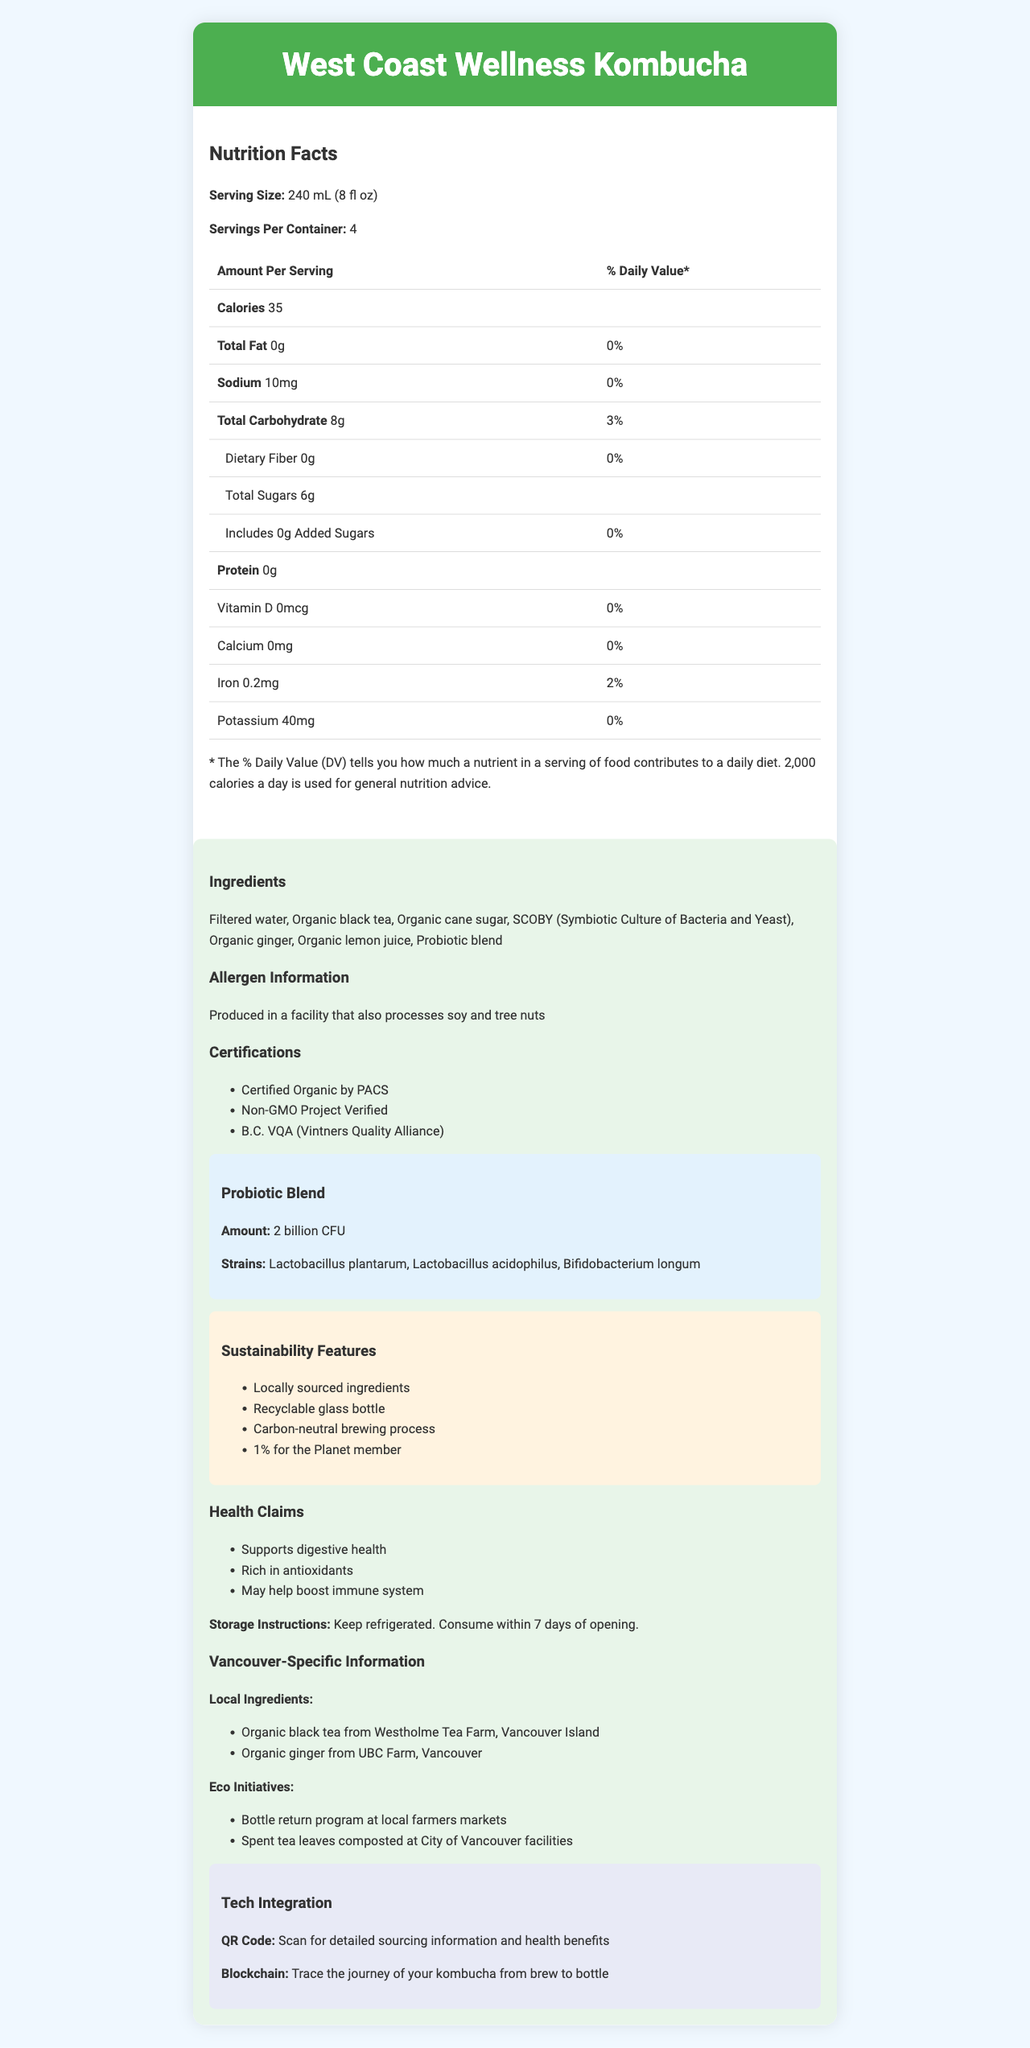how many servings are in a container? The document states that there are 4 servings per container.
Answer: 4 what is the serving size of the kombucha? The document lists the serving size as 240 mL (8 fl oz).
Answer: 240 mL (8 fl oz) how many calories are in one serving? The document indicates that each serving contains 35 calories.
Answer: 35 is there any fat in the West Coast Wellness Kombucha? The total fat amount is listed as 0g, which means there is no fat in the kombucha.
Answer: No what type of probiotics are included? The probiotics strains listed in the probiotic blend section are Lactobacillus plantarum, Lactobacillus acidophilus, and Bifidobacterium longum.
Answer: Lactobacillus plantarum, Lactobacillus acidophilus, Bifidobacterium longum which certification does the kombucha NOT have? A. Certified Organic by PACS B. Non-GMO Project Verified C. USDA Organic The document states that the kombucha is Certified Organic by PACS and Non-GMO Project Verified but does not mention USDA Organic.
Answer: C what is the amount of iron per serving? A. 0.1mg B. 0.2mg C. 0.3mg D. 0.4mg The document lists the iron content as 0.2mg per serving.
Answer: B should the kombucha be kept refrigerated after opening? The storage instructions mention that the kombucha should be refrigerated and consumed within 7 days of opening.
Answer: Yes does the product contain added sugars? The document states that the kombucha contains 0g of added sugars.
Answer: No is the kombucha bottle recyclable? The sustainability features list "Recyclable glass bottle" as one of its attributes.
Answer: Yes summarize the main idea of the document. The document outlines the kombucha's nutritional information and additional beneficial attributes like probiotics, uses of local and sustainable ingredients, technological integrations for traceability, and eco-friendly initiatives, making it appealing to health-conscious Vancouverites.
Answer: The document provides a comprehensive overview of the West Coast Wellness Kombucha, including its nutritional facts, ingredients, allergen information, certifications, probiotic blend details, sustainability features, health claims, storage instructions, and Vancouver-specific information. where is the organic black tea sourced from? The document states that the organic black tea is sourced from Westholme Tea Farm, Vancouver Island.
Answer: Westholme Tea Farm, Vancouver Island what is the sodium content in one serving of the kombucha? The document lists the sodium content as 10mg per serving.
Answer: 10mg how long does the kombucha last after opening? A. 3 days B. 5 days C. 7 days D. 10 days The storage instructions specify that the kombucha should be consumed within 7 days of opening.
Answer: C what is the daily value percentage for vitamin D? The document lists the daily value percentage for vitamin D as 0%.
Answer: 0% how many calories are there in two servings of the kombucha? Since one serving contains 35 calories, two servings would contain 35 x 2 = 70 calories.
Answer: 70 how can customers learn more about the sourcing information and health benefits? The document mentions that customers can scan a QR code for detailed sourcing information and health benefits.
Answer: By scanning the QR code what is the manufacturer's address? The document provides the manufacturer's address as 1234 Commercial Drive, Vancouver, BC V5L 3X5.
Answer: 1234 Commercial Drive, Vancouver, BC V5L 3X5 how is the brewing process environmentally friendly? The sustainability features list a carbon-neutral brewing process, indicating an environmentally friendly production method.
Answer: Carbon-neutral brewing process is there a bottle return program for the kombucha? The eco initiatives mentioned include a bottle return program at local farmers markets.
Answer: Yes what is the exact percentage of daily value for total carbohydrates per serving? A. 2% B. 3% C. 4% D. 5% The document states that the total carbohydrate daily value percentage per serving is 3%.
Answer: B what is the amount of dietary fiber per serving? The document states that there is 0g of dietary fiber per serving.
Answer: 0g where can consumers find detailed information about the kombucha's sustainability features? The document provides a brief list of sustainability features but does not specify where to find detailed information about them.
Answer: Not enough information 